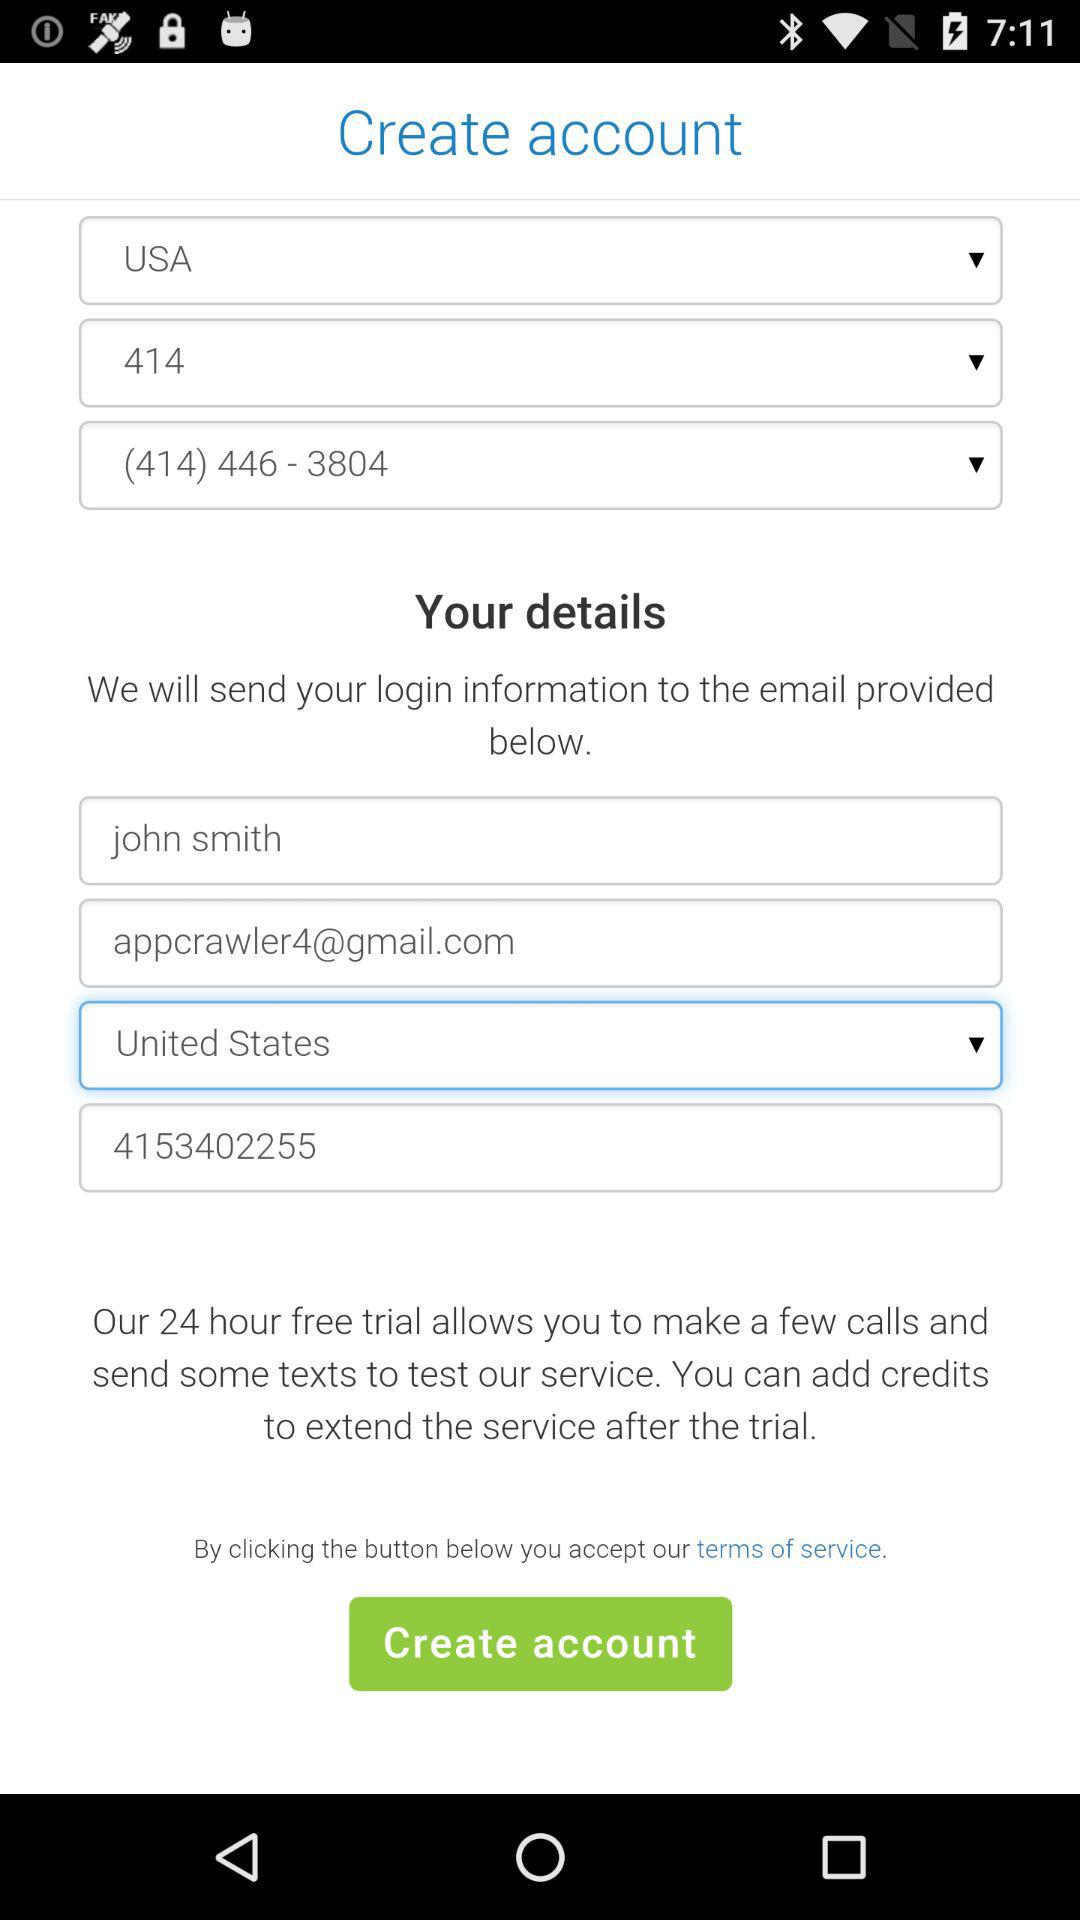What is the user name? The user name is John Smith. 